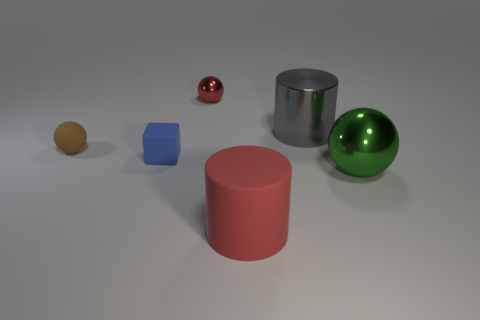How many rubber things are the same shape as the big gray shiny thing? There is one big red rubber cylinder that shares the same shape as the big gray cylinder, although they differ in color and material finish. 